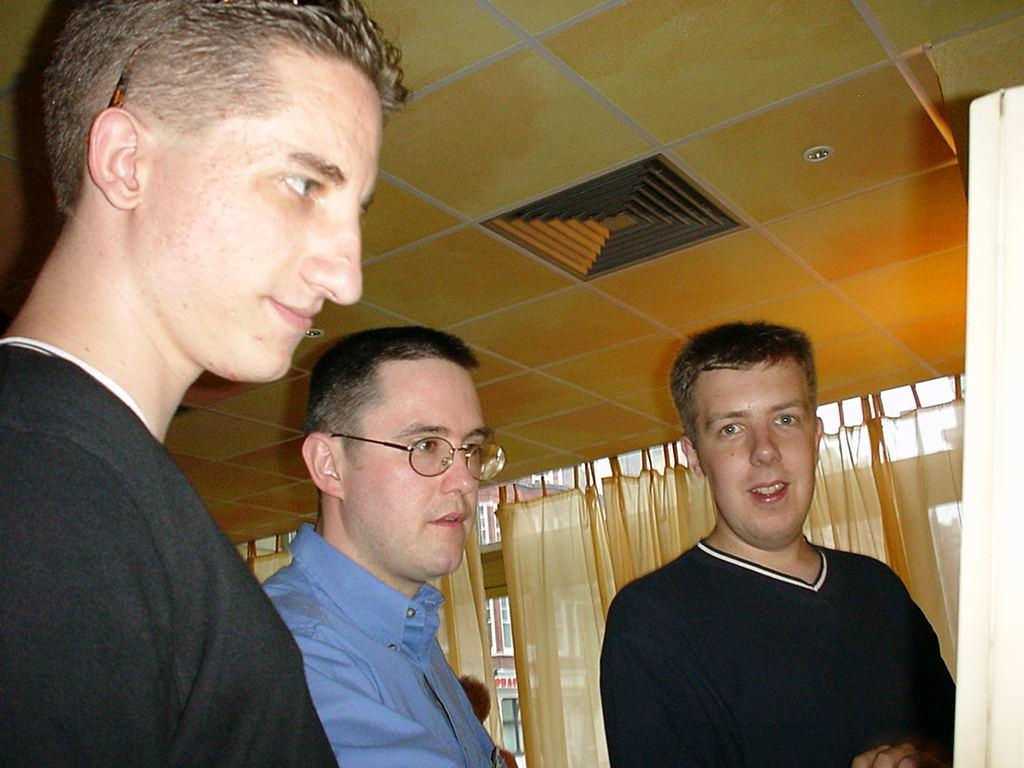How many people are present in the image? There are three men standing in the image. What can be seen in the background of the image? There are curtains in the background of the image. What type of wing is visible on the men in the image? There are no wings visible on the men in the image. How many locks can be seen securing the curtains in the image? There are no locks visible in the image, as it only features three men and curtains in the background. 